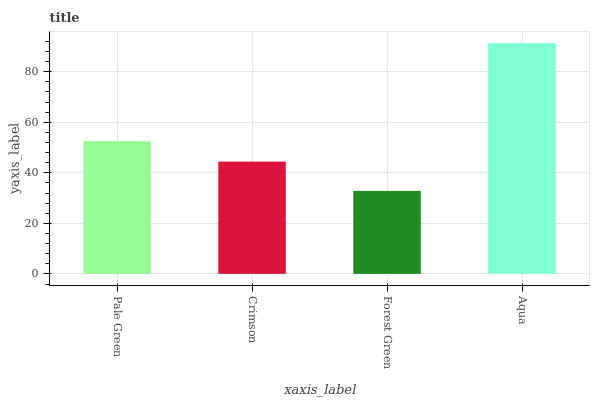Is Forest Green the minimum?
Answer yes or no. Yes. Is Aqua the maximum?
Answer yes or no. Yes. Is Crimson the minimum?
Answer yes or no. No. Is Crimson the maximum?
Answer yes or no. No. Is Pale Green greater than Crimson?
Answer yes or no. Yes. Is Crimson less than Pale Green?
Answer yes or no. Yes. Is Crimson greater than Pale Green?
Answer yes or no. No. Is Pale Green less than Crimson?
Answer yes or no. No. Is Pale Green the high median?
Answer yes or no. Yes. Is Crimson the low median?
Answer yes or no. Yes. Is Aqua the high median?
Answer yes or no. No. Is Aqua the low median?
Answer yes or no. No. 